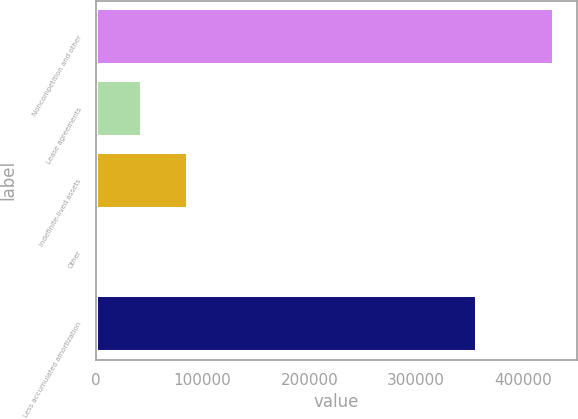<chart> <loc_0><loc_0><loc_500><loc_500><bar_chart><fcel>Noncompetition and other<fcel>Lease agreements<fcel>Indefinite-lived assets<fcel>Other<fcel>Less accumulated amortization<nl><fcel>429140<fcel>43438.7<fcel>86294.4<fcel>583<fcel>356774<nl></chart> 